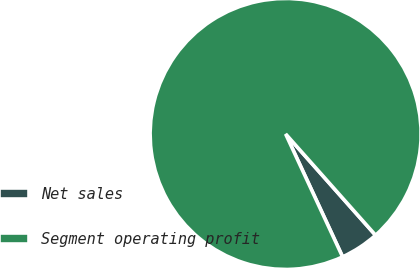<chart> <loc_0><loc_0><loc_500><loc_500><pie_chart><fcel>Net sales<fcel>Segment operating profit<nl><fcel>4.65%<fcel>95.35%<nl></chart> 